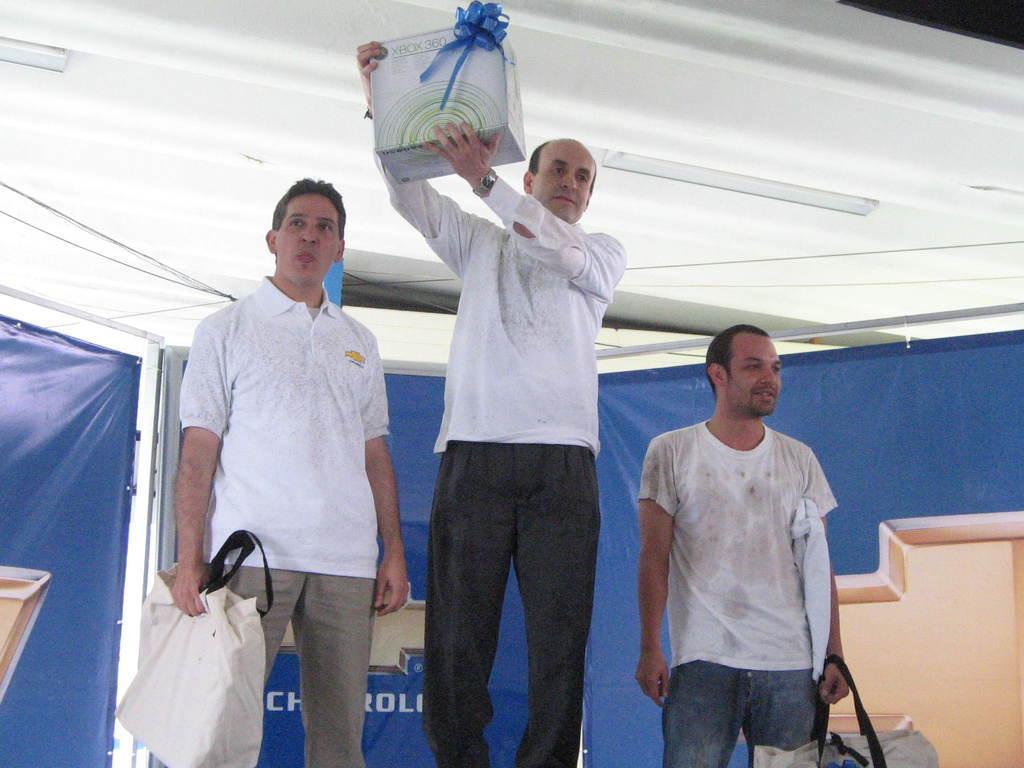Can you describe this image briefly? In this image in the front there are persons standing and holding objects in their hand which are white in colour. In the background there is a board which is blue in colour and on the board there is some text written on it. 